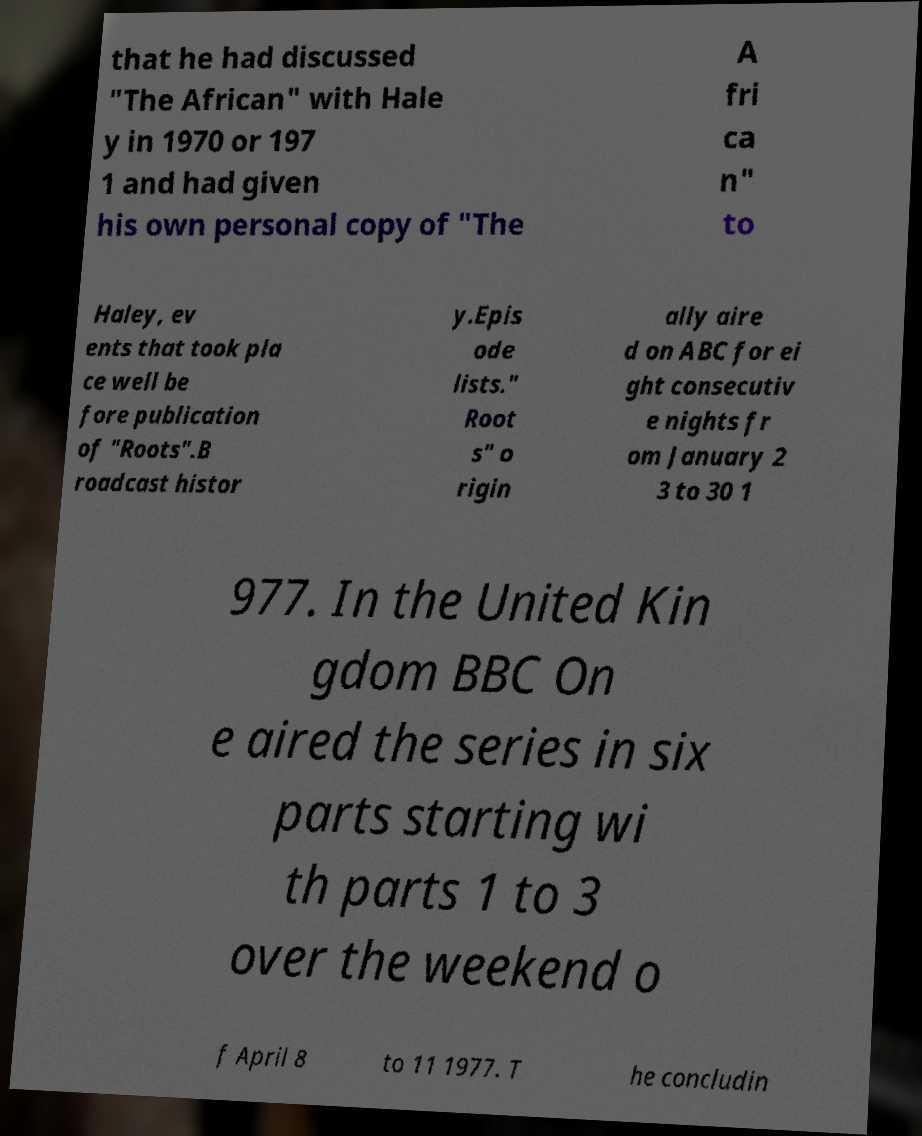Please read and relay the text visible in this image. What does it say? that he had discussed "The African" with Hale y in 1970 or 197 1 and had given his own personal copy of "The A fri ca n" to Haley, ev ents that took pla ce well be fore publication of "Roots".B roadcast histor y.Epis ode lists." Root s" o rigin ally aire d on ABC for ei ght consecutiv e nights fr om January 2 3 to 30 1 977. In the United Kin gdom BBC On e aired the series in six parts starting wi th parts 1 to 3 over the weekend o f April 8 to 11 1977. T he concludin 